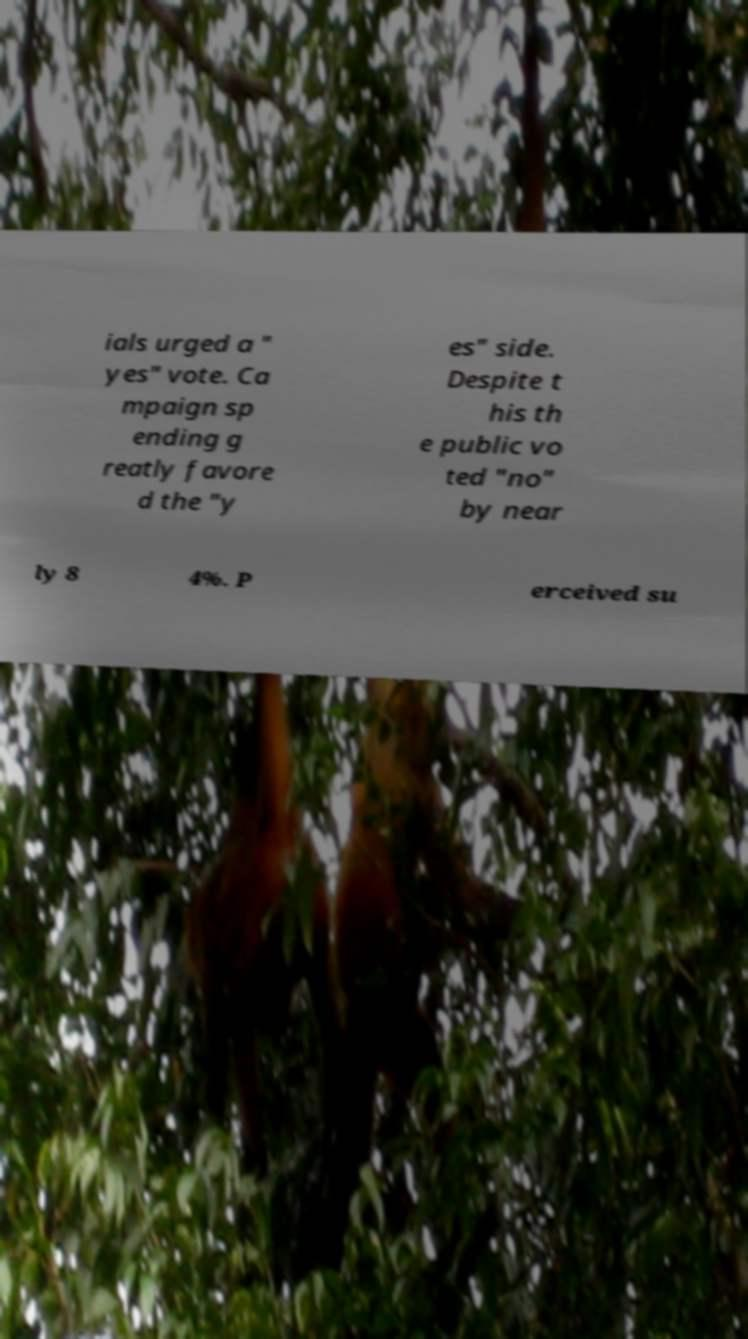For documentation purposes, I need the text within this image transcribed. Could you provide that? ials urged a " yes" vote. Ca mpaign sp ending g reatly favore d the "y es" side. Despite t his th e public vo ted "no" by near ly 8 4%. P erceived su 